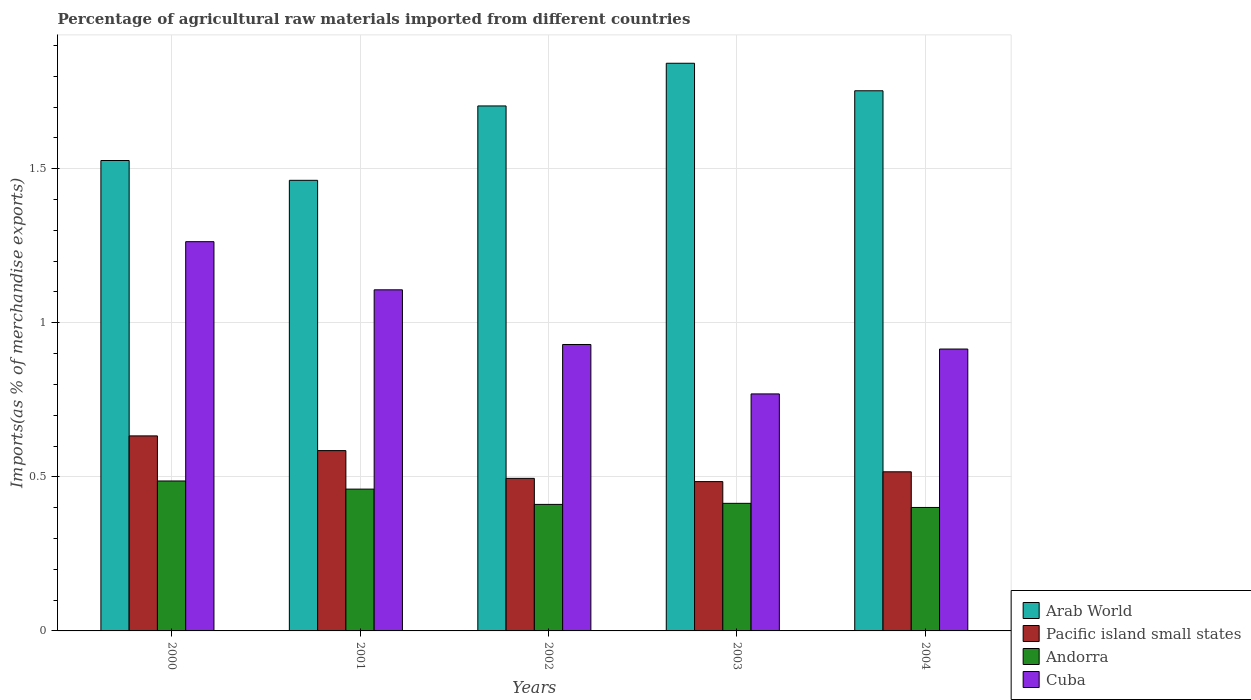How many groups of bars are there?
Offer a terse response. 5. Are the number of bars per tick equal to the number of legend labels?
Make the answer very short. Yes. How many bars are there on the 3rd tick from the left?
Provide a succinct answer. 4. What is the percentage of imports to different countries in Andorra in 2002?
Keep it short and to the point. 0.41. Across all years, what is the maximum percentage of imports to different countries in Cuba?
Ensure brevity in your answer.  1.26. Across all years, what is the minimum percentage of imports to different countries in Andorra?
Provide a succinct answer. 0.4. What is the total percentage of imports to different countries in Arab World in the graph?
Offer a terse response. 8.29. What is the difference between the percentage of imports to different countries in Arab World in 2002 and that in 2004?
Make the answer very short. -0.05. What is the difference between the percentage of imports to different countries in Cuba in 2000 and the percentage of imports to different countries in Arab World in 2001?
Your answer should be very brief. -0.2. What is the average percentage of imports to different countries in Andorra per year?
Your response must be concise. 0.43. In the year 2000, what is the difference between the percentage of imports to different countries in Arab World and percentage of imports to different countries in Cuba?
Your answer should be compact. 0.26. In how many years, is the percentage of imports to different countries in Pacific island small states greater than 0.6 %?
Your answer should be very brief. 1. What is the ratio of the percentage of imports to different countries in Cuba in 2001 to that in 2003?
Provide a short and direct response. 1.44. Is the difference between the percentage of imports to different countries in Arab World in 2000 and 2001 greater than the difference between the percentage of imports to different countries in Cuba in 2000 and 2001?
Your answer should be very brief. No. What is the difference between the highest and the second highest percentage of imports to different countries in Cuba?
Keep it short and to the point. 0.16. What is the difference between the highest and the lowest percentage of imports to different countries in Cuba?
Provide a succinct answer. 0.49. In how many years, is the percentage of imports to different countries in Arab World greater than the average percentage of imports to different countries in Arab World taken over all years?
Your response must be concise. 3. Is the sum of the percentage of imports to different countries in Arab World in 2002 and 2003 greater than the maximum percentage of imports to different countries in Cuba across all years?
Your answer should be compact. Yes. What does the 1st bar from the left in 2001 represents?
Your response must be concise. Arab World. What does the 4th bar from the right in 2003 represents?
Your response must be concise. Arab World. Are all the bars in the graph horizontal?
Offer a terse response. No. What is the difference between two consecutive major ticks on the Y-axis?
Keep it short and to the point. 0.5. Does the graph contain any zero values?
Your response must be concise. No. Where does the legend appear in the graph?
Your response must be concise. Bottom right. How are the legend labels stacked?
Your answer should be compact. Vertical. What is the title of the graph?
Your response must be concise. Percentage of agricultural raw materials imported from different countries. Does "Macao" appear as one of the legend labels in the graph?
Your response must be concise. No. What is the label or title of the Y-axis?
Ensure brevity in your answer.  Imports(as % of merchandise exports). What is the Imports(as % of merchandise exports) in Arab World in 2000?
Provide a short and direct response. 1.53. What is the Imports(as % of merchandise exports) of Pacific island small states in 2000?
Your answer should be compact. 0.63. What is the Imports(as % of merchandise exports) in Andorra in 2000?
Provide a succinct answer. 0.49. What is the Imports(as % of merchandise exports) of Cuba in 2000?
Your answer should be very brief. 1.26. What is the Imports(as % of merchandise exports) in Arab World in 2001?
Your response must be concise. 1.46. What is the Imports(as % of merchandise exports) of Pacific island small states in 2001?
Keep it short and to the point. 0.59. What is the Imports(as % of merchandise exports) in Andorra in 2001?
Provide a succinct answer. 0.46. What is the Imports(as % of merchandise exports) of Cuba in 2001?
Ensure brevity in your answer.  1.11. What is the Imports(as % of merchandise exports) of Arab World in 2002?
Keep it short and to the point. 1.7. What is the Imports(as % of merchandise exports) of Pacific island small states in 2002?
Your response must be concise. 0.5. What is the Imports(as % of merchandise exports) in Andorra in 2002?
Your response must be concise. 0.41. What is the Imports(as % of merchandise exports) of Cuba in 2002?
Your answer should be very brief. 0.93. What is the Imports(as % of merchandise exports) of Arab World in 2003?
Provide a short and direct response. 1.84. What is the Imports(as % of merchandise exports) in Pacific island small states in 2003?
Your answer should be very brief. 0.48. What is the Imports(as % of merchandise exports) of Andorra in 2003?
Give a very brief answer. 0.41. What is the Imports(as % of merchandise exports) in Cuba in 2003?
Keep it short and to the point. 0.77. What is the Imports(as % of merchandise exports) in Arab World in 2004?
Your answer should be very brief. 1.75. What is the Imports(as % of merchandise exports) in Pacific island small states in 2004?
Make the answer very short. 0.52. What is the Imports(as % of merchandise exports) of Andorra in 2004?
Provide a succinct answer. 0.4. What is the Imports(as % of merchandise exports) in Cuba in 2004?
Provide a short and direct response. 0.91. Across all years, what is the maximum Imports(as % of merchandise exports) of Arab World?
Your answer should be compact. 1.84. Across all years, what is the maximum Imports(as % of merchandise exports) in Pacific island small states?
Offer a terse response. 0.63. Across all years, what is the maximum Imports(as % of merchandise exports) in Andorra?
Offer a terse response. 0.49. Across all years, what is the maximum Imports(as % of merchandise exports) of Cuba?
Ensure brevity in your answer.  1.26. Across all years, what is the minimum Imports(as % of merchandise exports) in Arab World?
Provide a short and direct response. 1.46. Across all years, what is the minimum Imports(as % of merchandise exports) in Pacific island small states?
Your response must be concise. 0.48. Across all years, what is the minimum Imports(as % of merchandise exports) of Andorra?
Provide a succinct answer. 0.4. Across all years, what is the minimum Imports(as % of merchandise exports) in Cuba?
Offer a terse response. 0.77. What is the total Imports(as % of merchandise exports) of Arab World in the graph?
Ensure brevity in your answer.  8.29. What is the total Imports(as % of merchandise exports) of Pacific island small states in the graph?
Your answer should be compact. 2.71. What is the total Imports(as % of merchandise exports) in Andorra in the graph?
Ensure brevity in your answer.  2.17. What is the total Imports(as % of merchandise exports) in Cuba in the graph?
Your response must be concise. 4.98. What is the difference between the Imports(as % of merchandise exports) in Arab World in 2000 and that in 2001?
Ensure brevity in your answer.  0.06. What is the difference between the Imports(as % of merchandise exports) in Pacific island small states in 2000 and that in 2001?
Provide a succinct answer. 0.05. What is the difference between the Imports(as % of merchandise exports) of Andorra in 2000 and that in 2001?
Give a very brief answer. 0.03. What is the difference between the Imports(as % of merchandise exports) of Cuba in 2000 and that in 2001?
Ensure brevity in your answer.  0.16. What is the difference between the Imports(as % of merchandise exports) in Arab World in 2000 and that in 2002?
Ensure brevity in your answer.  -0.18. What is the difference between the Imports(as % of merchandise exports) in Pacific island small states in 2000 and that in 2002?
Offer a terse response. 0.14. What is the difference between the Imports(as % of merchandise exports) in Andorra in 2000 and that in 2002?
Ensure brevity in your answer.  0.08. What is the difference between the Imports(as % of merchandise exports) in Cuba in 2000 and that in 2002?
Keep it short and to the point. 0.33. What is the difference between the Imports(as % of merchandise exports) in Arab World in 2000 and that in 2003?
Give a very brief answer. -0.32. What is the difference between the Imports(as % of merchandise exports) of Pacific island small states in 2000 and that in 2003?
Provide a short and direct response. 0.15. What is the difference between the Imports(as % of merchandise exports) of Andorra in 2000 and that in 2003?
Keep it short and to the point. 0.07. What is the difference between the Imports(as % of merchandise exports) of Cuba in 2000 and that in 2003?
Give a very brief answer. 0.49. What is the difference between the Imports(as % of merchandise exports) of Arab World in 2000 and that in 2004?
Ensure brevity in your answer.  -0.23. What is the difference between the Imports(as % of merchandise exports) of Pacific island small states in 2000 and that in 2004?
Make the answer very short. 0.12. What is the difference between the Imports(as % of merchandise exports) in Andorra in 2000 and that in 2004?
Your answer should be very brief. 0.09. What is the difference between the Imports(as % of merchandise exports) in Cuba in 2000 and that in 2004?
Offer a very short reply. 0.35. What is the difference between the Imports(as % of merchandise exports) of Arab World in 2001 and that in 2002?
Give a very brief answer. -0.24. What is the difference between the Imports(as % of merchandise exports) of Pacific island small states in 2001 and that in 2002?
Your answer should be very brief. 0.09. What is the difference between the Imports(as % of merchandise exports) in Andorra in 2001 and that in 2002?
Your response must be concise. 0.05. What is the difference between the Imports(as % of merchandise exports) of Cuba in 2001 and that in 2002?
Your answer should be compact. 0.18. What is the difference between the Imports(as % of merchandise exports) of Arab World in 2001 and that in 2003?
Ensure brevity in your answer.  -0.38. What is the difference between the Imports(as % of merchandise exports) of Pacific island small states in 2001 and that in 2003?
Make the answer very short. 0.1. What is the difference between the Imports(as % of merchandise exports) in Andorra in 2001 and that in 2003?
Provide a short and direct response. 0.05. What is the difference between the Imports(as % of merchandise exports) of Cuba in 2001 and that in 2003?
Make the answer very short. 0.34. What is the difference between the Imports(as % of merchandise exports) in Arab World in 2001 and that in 2004?
Offer a terse response. -0.29. What is the difference between the Imports(as % of merchandise exports) of Pacific island small states in 2001 and that in 2004?
Provide a short and direct response. 0.07. What is the difference between the Imports(as % of merchandise exports) in Andorra in 2001 and that in 2004?
Your answer should be very brief. 0.06. What is the difference between the Imports(as % of merchandise exports) of Cuba in 2001 and that in 2004?
Your response must be concise. 0.19. What is the difference between the Imports(as % of merchandise exports) in Arab World in 2002 and that in 2003?
Offer a terse response. -0.14. What is the difference between the Imports(as % of merchandise exports) in Pacific island small states in 2002 and that in 2003?
Your response must be concise. 0.01. What is the difference between the Imports(as % of merchandise exports) in Andorra in 2002 and that in 2003?
Give a very brief answer. -0. What is the difference between the Imports(as % of merchandise exports) of Cuba in 2002 and that in 2003?
Your answer should be very brief. 0.16. What is the difference between the Imports(as % of merchandise exports) of Arab World in 2002 and that in 2004?
Give a very brief answer. -0.05. What is the difference between the Imports(as % of merchandise exports) of Pacific island small states in 2002 and that in 2004?
Offer a very short reply. -0.02. What is the difference between the Imports(as % of merchandise exports) of Andorra in 2002 and that in 2004?
Your answer should be very brief. 0.01. What is the difference between the Imports(as % of merchandise exports) of Cuba in 2002 and that in 2004?
Give a very brief answer. 0.01. What is the difference between the Imports(as % of merchandise exports) of Arab World in 2003 and that in 2004?
Your response must be concise. 0.09. What is the difference between the Imports(as % of merchandise exports) of Pacific island small states in 2003 and that in 2004?
Give a very brief answer. -0.03. What is the difference between the Imports(as % of merchandise exports) in Andorra in 2003 and that in 2004?
Provide a short and direct response. 0.01. What is the difference between the Imports(as % of merchandise exports) of Cuba in 2003 and that in 2004?
Provide a succinct answer. -0.15. What is the difference between the Imports(as % of merchandise exports) of Arab World in 2000 and the Imports(as % of merchandise exports) of Pacific island small states in 2001?
Your answer should be compact. 0.94. What is the difference between the Imports(as % of merchandise exports) in Arab World in 2000 and the Imports(as % of merchandise exports) in Andorra in 2001?
Your answer should be compact. 1.07. What is the difference between the Imports(as % of merchandise exports) of Arab World in 2000 and the Imports(as % of merchandise exports) of Cuba in 2001?
Your answer should be very brief. 0.42. What is the difference between the Imports(as % of merchandise exports) of Pacific island small states in 2000 and the Imports(as % of merchandise exports) of Andorra in 2001?
Your response must be concise. 0.17. What is the difference between the Imports(as % of merchandise exports) in Pacific island small states in 2000 and the Imports(as % of merchandise exports) in Cuba in 2001?
Offer a terse response. -0.47. What is the difference between the Imports(as % of merchandise exports) in Andorra in 2000 and the Imports(as % of merchandise exports) in Cuba in 2001?
Your answer should be very brief. -0.62. What is the difference between the Imports(as % of merchandise exports) in Arab World in 2000 and the Imports(as % of merchandise exports) in Pacific island small states in 2002?
Ensure brevity in your answer.  1.03. What is the difference between the Imports(as % of merchandise exports) in Arab World in 2000 and the Imports(as % of merchandise exports) in Andorra in 2002?
Give a very brief answer. 1.12. What is the difference between the Imports(as % of merchandise exports) in Arab World in 2000 and the Imports(as % of merchandise exports) in Cuba in 2002?
Your answer should be compact. 0.6. What is the difference between the Imports(as % of merchandise exports) of Pacific island small states in 2000 and the Imports(as % of merchandise exports) of Andorra in 2002?
Ensure brevity in your answer.  0.22. What is the difference between the Imports(as % of merchandise exports) of Pacific island small states in 2000 and the Imports(as % of merchandise exports) of Cuba in 2002?
Provide a succinct answer. -0.3. What is the difference between the Imports(as % of merchandise exports) of Andorra in 2000 and the Imports(as % of merchandise exports) of Cuba in 2002?
Provide a succinct answer. -0.44. What is the difference between the Imports(as % of merchandise exports) of Arab World in 2000 and the Imports(as % of merchandise exports) of Pacific island small states in 2003?
Give a very brief answer. 1.04. What is the difference between the Imports(as % of merchandise exports) in Arab World in 2000 and the Imports(as % of merchandise exports) in Andorra in 2003?
Ensure brevity in your answer.  1.11. What is the difference between the Imports(as % of merchandise exports) in Arab World in 2000 and the Imports(as % of merchandise exports) in Cuba in 2003?
Your response must be concise. 0.76. What is the difference between the Imports(as % of merchandise exports) of Pacific island small states in 2000 and the Imports(as % of merchandise exports) of Andorra in 2003?
Offer a very short reply. 0.22. What is the difference between the Imports(as % of merchandise exports) of Pacific island small states in 2000 and the Imports(as % of merchandise exports) of Cuba in 2003?
Offer a terse response. -0.14. What is the difference between the Imports(as % of merchandise exports) of Andorra in 2000 and the Imports(as % of merchandise exports) of Cuba in 2003?
Make the answer very short. -0.28. What is the difference between the Imports(as % of merchandise exports) in Arab World in 2000 and the Imports(as % of merchandise exports) in Pacific island small states in 2004?
Your answer should be compact. 1.01. What is the difference between the Imports(as % of merchandise exports) of Arab World in 2000 and the Imports(as % of merchandise exports) of Andorra in 2004?
Offer a terse response. 1.13. What is the difference between the Imports(as % of merchandise exports) of Arab World in 2000 and the Imports(as % of merchandise exports) of Cuba in 2004?
Offer a terse response. 0.61. What is the difference between the Imports(as % of merchandise exports) in Pacific island small states in 2000 and the Imports(as % of merchandise exports) in Andorra in 2004?
Your answer should be very brief. 0.23. What is the difference between the Imports(as % of merchandise exports) of Pacific island small states in 2000 and the Imports(as % of merchandise exports) of Cuba in 2004?
Your response must be concise. -0.28. What is the difference between the Imports(as % of merchandise exports) of Andorra in 2000 and the Imports(as % of merchandise exports) of Cuba in 2004?
Provide a succinct answer. -0.43. What is the difference between the Imports(as % of merchandise exports) of Arab World in 2001 and the Imports(as % of merchandise exports) of Pacific island small states in 2002?
Keep it short and to the point. 0.97. What is the difference between the Imports(as % of merchandise exports) of Arab World in 2001 and the Imports(as % of merchandise exports) of Andorra in 2002?
Your answer should be very brief. 1.05. What is the difference between the Imports(as % of merchandise exports) of Arab World in 2001 and the Imports(as % of merchandise exports) of Cuba in 2002?
Make the answer very short. 0.53. What is the difference between the Imports(as % of merchandise exports) of Pacific island small states in 2001 and the Imports(as % of merchandise exports) of Andorra in 2002?
Your response must be concise. 0.17. What is the difference between the Imports(as % of merchandise exports) in Pacific island small states in 2001 and the Imports(as % of merchandise exports) in Cuba in 2002?
Give a very brief answer. -0.34. What is the difference between the Imports(as % of merchandise exports) in Andorra in 2001 and the Imports(as % of merchandise exports) in Cuba in 2002?
Your answer should be compact. -0.47. What is the difference between the Imports(as % of merchandise exports) in Arab World in 2001 and the Imports(as % of merchandise exports) in Pacific island small states in 2003?
Offer a terse response. 0.98. What is the difference between the Imports(as % of merchandise exports) in Arab World in 2001 and the Imports(as % of merchandise exports) in Andorra in 2003?
Keep it short and to the point. 1.05. What is the difference between the Imports(as % of merchandise exports) of Arab World in 2001 and the Imports(as % of merchandise exports) of Cuba in 2003?
Offer a very short reply. 0.69. What is the difference between the Imports(as % of merchandise exports) in Pacific island small states in 2001 and the Imports(as % of merchandise exports) in Andorra in 2003?
Offer a terse response. 0.17. What is the difference between the Imports(as % of merchandise exports) of Pacific island small states in 2001 and the Imports(as % of merchandise exports) of Cuba in 2003?
Your answer should be very brief. -0.18. What is the difference between the Imports(as % of merchandise exports) of Andorra in 2001 and the Imports(as % of merchandise exports) of Cuba in 2003?
Give a very brief answer. -0.31. What is the difference between the Imports(as % of merchandise exports) of Arab World in 2001 and the Imports(as % of merchandise exports) of Pacific island small states in 2004?
Give a very brief answer. 0.95. What is the difference between the Imports(as % of merchandise exports) of Arab World in 2001 and the Imports(as % of merchandise exports) of Andorra in 2004?
Provide a short and direct response. 1.06. What is the difference between the Imports(as % of merchandise exports) in Arab World in 2001 and the Imports(as % of merchandise exports) in Cuba in 2004?
Keep it short and to the point. 0.55. What is the difference between the Imports(as % of merchandise exports) in Pacific island small states in 2001 and the Imports(as % of merchandise exports) in Andorra in 2004?
Offer a terse response. 0.18. What is the difference between the Imports(as % of merchandise exports) of Pacific island small states in 2001 and the Imports(as % of merchandise exports) of Cuba in 2004?
Make the answer very short. -0.33. What is the difference between the Imports(as % of merchandise exports) of Andorra in 2001 and the Imports(as % of merchandise exports) of Cuba in 2004?
Provide a succinct answer. -0.45. What is the difference between the Imports(as % of merchandise exports) of Arab World in 2002 and the Imports(as % of merchandise exports) of Pacific island small states in 2003?
Provide a succinct answer. 1.22. What is the difference between the Imports(as % of merchandise exports) of Arab World in 2002 and the Imports(as % of merchandise exports) of Andorra in 2003?
Your response must be concise. 1.29. What is the difference between the Imports(as % of merchandise exports) of Arab World in 2002 and the Imports(as % of merchandise exports) of Cuba in 2003?
Keep it short and to the point. 0.93. What is the difference between the Imports(as % of merchandise exports) in Pacific island small states in 2002 and the Imports(as % of merchandise exports) in Andorra in 2003?
Ensure brevity in your answer.  0.08. What is the difference between the Imports(as % of merchandise exports) in Pacific island small states in 2002 and the Imports(as % of merchandise exports) in Cuba in 2003?
Make the answer very short. -0.27. What is the difference between the Imports(as % of merchandise exports) in Andorra in 2002 and the Imports(as % of merchandise exports) in Cuba in 2003?
Keep it short and to the point. -0.36. What is the difference between the Imports(as % of merchandise exports) of Arab World in 2002 and the Imports(as % of merchandise exports) of Pacific island small states in 2004?
Give a very brief answer. 1.19. What is the difference between the Imports(as % of merchandise exports) in Arab World in 2002 and the Imports(as % of merchandise exports) in Andorra in 2004?
Your answer should be compact. 1.3. What is the difference between the Imports(as % of merchandise exports) in Arab World in 2002 and the Imports(as % of merchandise exports) in Cuba in 2004?
Make the answer very short. 0.79. What is the difference between the Imports(as % of merchandise exports) in Pacific island small states in 2002 and the Imports(as % of merchandise exports) in Andorra in 2004?
Keep it short and to the point. 0.09. What is the difference between the Imports(as % of merchandise exports) in Pacific island small states in 2002 and the Imports(as % of merchandise exports) in Cuba in 2004?
Your response must be concise. -0.42. What is the difference between the Imports(as % of merchandise exports) in Andorra in 2002 and the Imports(as % of merchandise exports) in Cuba in 2004?
Make the answer very short. -0.5. What is the difference between the Imports(as % of merchandise exports) in Arab World in 2003 and the Imports(as % of merchandise exports) in Pacific island small states in 2004?
Make the answer very short. 1.33. What is the difference between the Imports(as % of merchandise exports) of Arab World in 2003 and the Imports(as % of merchandise exports) of Andorra in 2004?
Provide a short and direct response. 1.44. What is the difference between the Imports(as % of merchandise exports) of Arab World in 2003 and the Imports(as % of merchandise exports) of Cuba in 2004?
Ensure brevity in your answer.  0.93. What is the difference between the Imports(as % of merchandise exports) in Pacific island small states in 2003 and the Imports(as % of merchandise exports) in Andorra in 2004?
Your answer should be very brief. 0.08. What is the difference between the Imports(as % of merchandise exports) of Pacific island small states in 2003 and the Imports(as % of merchandise exports) of Cuba in 2004?
Make the answer very short. -0.43. What is the difference between the Imports(as % of merchandise exports) of Andorra in 2003 and the Imports(as % of merchandise exports) of Cuba in 2004?
Offer a very short reply. -0.5. What is the average Imports(as % of merchandise exports) in Arab World per year?
Offer a very short reply. 1.66. What is the average Imports(as % of merchandise exports) of Pacific island small states per year?
Keep it short and to the point. 0.54. What is the average Imports(as % of merchandise exports) in Andorra per year?
Your response must be concise. 0.43. What is the average Imports(as % of merchandise exports) in Cuba per year?
Offer a terse response. 1. In the year 2000, what is the difference between the Imports(as % of merchandise exports) of Arab World and Imports(as % of merchandise exports) of Pacific island small states?
Your answer should be compact. 0.89. In the year 2000, what is the difference between the Imports(as % of merchandise exports) of Arab World and Imports(as % of merchandise exports) of Cuba?
Offer a terse response. 0.26. In the year 2000, what is the difference between the Imports(as % of merchandise exports) of Pacific island small states and Imports(as % of merchandise exports) of Andorra?
Provide a short and direct response. 0.15. In the year 2000, what is the difference between the Imports(as % of merchandise exports) of Pacific island small states and Imports(as % of merchandise exports) of Cuba?
Your response must be concise. -0.63. In the year 2000, what is the difference between the Imports(as % of merchandise exports) in Andorra and Imports(as % of merchandise exports) in Cuba?
Keep it short and to the point. -0.78. In the year 2001, what is the difference between the Imports(as % of merchandise exports) in Arab World and Imports(as % of merchandise exports) in Pacific island small states?
Your answer should be compact. 0.88. In the year 2001, what is the difference between the Imports(as % of merchandise exports) of Arab World and Imports(as % of merchandise exports) of Cuba?
Offer a very short reply. 0.36. In the year 2001, what is the difference between the Imports(as % of merchandise exports) of Pacific island small states and Imports(as % of merchandise exports) of Andorra?
Keep it short and to the point. 0.12. In the year 2001, what is the difference between the Imports(as % of merchandise exports) in Pacific island small states and Imports(as % of merchandise exports) in Cuba?
Your answer should be very brief. -0.52. In the year 2001, what is the difference between the Imports(as % of merchandise exports) of Andorra and Imports(as % of merchandise exports) of Cuba?
Provide a succinct answer. -0.65. In the year 2002, what is the difference between the Imports(as % of merchandise exports) of Arab World and Imports(as % of merchandise exports) of Pacific island small states?
Offer a very short reply. 1.21. In the year 2002, what is the difference between the Imports(as % of merchandise exports) in Arab World and Imports(as % of merchandise exports) in Andorra?
Provide a succinct answer. 1.29. In the year 2002, what is the difference between the Imports(as % of merchandise exports) in Arab World and Imports(as % of merchandise exports) in Cuba?
Your answer should be compact. 0.77. In the year 2002, what is the difference between the Imports(as % of merchandise exports) in Pacific island small states and Imports(as % of merchandise exports) in Andorra?
Provide a succinct answer. 0.08. In the year 2002, what is the difference between the Imports(as % of merchandise exports) of Pacific island small states and Imports(as % of merchandise exports) of Cuba?
Your answer should be compact. -0.43. In the year 2002, what is the difference between the Imports(as % of merchandise exports) in Andorra and Imports(as % of merchandise exports) in Cuba?
Your response must be concise. -0.52. In the year 2003, what is the difference between the Imports(as % of merchandise exports) in Arab World and Imports(as % of merchandise exports) in Pacific island small states?
Make the answer very short. 1.36. In the year 2003, what is the difference between the Imports(as % of merchandise exports) of Arab World and Imports(as % of merchandise exports) of Andorra?
Offer a terse response. 1.43. In the year 2003, what is the difference between the Imports(as % of merchandise exports) in Arab World and Imports(as % of merchandise exports) in Cuba?
Give a very brief answer. 1.07. In the year 2003, what is the difference between the Imports(as % of merchandise exports) of Pacific island small states and Imports(as % of merchandise exports) of Andorra?
Offer a terse response. 0.07. In the year 2003, what is the difference between the Imports(as % of merchandise exports) of Pacific island small states and Imports(as % of merchandise exports) of Cuba?
Provide a succinct answer. -0.28. In the year 2003, what is the difference between the Imports(as % of merchandise exports) in Andorra and Imports(as % of merchandise exports) in Cuba?
Provide a short and direct response. -0.36. In the year 2004, what is the difference between the Imports(as % of merchandise exports) in Arab World and Imports(as % of merchandise exports) in Pacific island small states?
Keep it short and to the point. 1.24. In the year 2004, what is the difference between the Imports(as % of merchandise exports) in Arab World and Imports(as % of merchandise exports) in Andorra?
Your response must be concise. 1.35. In the year 2004, what is the difference between the Imports(as % of merchandise exports) of Arab World and Imports(as % of merchandise exports) of Cuba?
Make the answer very short. 0.84. In the year 2004, what is the difference between the Imports(as % of merchandise exports) in Pacific island small states and Imports(as % of merchandise exports) in Andorra?
Your answer should be very brief. 0.12. In the year 2004, what is the difference between the Imports(as % of merchandise exports) in Pacific island small states and Imports(as % of merchandise exports) in Cuba?
Your response must be concise. -0.4. In the year 2004, what is the difference between the Imports(as % of merchandise exports) of Andorra and Imports(as % of merchandise exports) of Cuba?
Your answer should be compact. -0.51. What is the ratio of the Imports(as % of merchandise exports) of Arab World in 2000 to that in 2001?
Your answer should be very brief. 1.04. What is the ratio of the Imports(as % of merchandise exports) of Pacific island small states in 2000 to that in 2001?
Your answer should be compact. 1.08. What is the ratio of the Imports(as % of merchandise exports) in Andorra in 2000 to that in 2001?
Your answer should be very brief. 1.06. What is the ratio of the Imports(as % of merchandise exports) in Cuba in 2000 to that in 2001?
Provide a succinct answer. 1.14. What is the ratio of the Imports(as % of merchandise exports) in Arab World in 2000 to that in 2002?
Your answer should be compact. 0.9. What is the ratio of the Imports(as % of merchandise exports) in Pacific island small states in 2000 to that in 2002?
Keep it short and to the point. 1.28. What is the ratio of the Imports(as % of merchandise exports) of Andorra in 2000 to that in 2002?
Your response must be concise. 1.19. What is the ratio of the Imports(as % of merchandise exports) of Cuba in 2000 to that in 2002?
Give a very brief answer. 1.36. What is the ratio of the Imports(as % of merchandise exports) in Arab World in 2000 to that in 2003?
Offer a terse response. 0.83. What is the ratio of the Imports(as % of merchandise exports) in Pacific island small states in 2000 to that in 2003?
Offer a very short reply. 1.31. What is the ratio of the Imports(as % of merchandise exports) of Andorra in 2000 to that in 2003?
Ensure brevity in your answer.  1.18. What is the ratio of the Imports(as % of merchandise exports) in Cuba in 2000 to that in 2003?
Offer a terse response. 1.64. What is the ratio of the Imports(as % of merchandise exports) in Arab World in 2000 to that in 2004?
Give a very brief answer. 0.87. What is the ratio of the Imports(as % of merchandise exports) of Pacific island small states in 2000 to that in 2004?
Your response must be concise. 1.23. What is the ratio of the Imports(as % of merchandise exports) of Andorra in 2000 to that in 2004?
Provide a short and direct response. 1.21. What is the ratio of the Imports(as % of merchandise exports) of Cuba in 2000 to that in 2004?
Your answer should be very brief. 1.38. What is the ratio of the Imports(as % of merchandise exports) of Arab World in 2001 to that in 2002?
Offer a terse response. 0.86. What is the ratio of the Imports(as % of merchandise exports) of Pacific island small states in 2001 to that in 2002?
Give a very brief answer. 1.18. What is the ratio of the Imports(as % of merchandise exports) in Andorra in 2001 to that in 2002?
Your answer should be compact. 1.12. What is the ratio of the Imports(as % of merchandise exports) in Cuba in 2001 to that in 2002?
Your answer should be very brief. 1.19. What is the ratio of the Imports(as % of merchandise exports) in Arab World in 2001 to that in 2003?
Make the answer very short. 0.79. What is the ratio of the Imports(as % of merchandise exports) in Pacific island small states in 2001 to that in 2003?
Offer a very short reply. 1.21. What is the ratio of the Imports(as % of merchandise exports) of Andorra in 2001 to that in 2003?
Offer a very short reply. 1.11. What is the ratio of the Imports(as % of merchandise exports) in Cuba in 2001 to that in 2003?
Your response must be concise. 1.44. What is the ratio of the Imports(as % of merchandise exports) of Arab World in 2001 to that in 2004?
Provide a succinct answer. 0.83. What is the ratio of the Imports(as % of merchandise exports) of Pacific island small states in 2001 to that in 2004?
Your answer should be compact. 1.13. What is the ratio of the Imports(as % of merchandise exports) in Andorra in 2001 to that in 2004?
Keep it short and to the point. 1.15. What is the ratio of the Imports(as % of merchandise exports) of Cuba in 2001 to that in 2004?
Provide a succinct answer. 1.21. What is the ratio of the Imports(as % of merchandise exports) in Arab World in 2002 to that in 2003?
Offer a terse response. 0.92. What is the ratio of the Imports(as % of merchandise exports) in Pacific island small states in 2002 to that in 2003?
Make the answer very short. 1.02. What is the ratio of the Imports(as % of merchandise exports) in Andorra in 2002 to that in 2003?
Make the answer very short. 0.99. What is the ratio of the Imports(as % of merchandise exports) of Cuba in 2002 to that in 2003?
Make the answer very short. 1.21. What is the ratio of the Imports(as % of merchandise exports) of Arab World in 2002 to that in 2004?
Ensure brevity in your answer.  0.97. What is the ratio of the Imports(as % of merchandise exports) in Pacific island small states in 2002 to that in 2004?
Your answer should be compact. 0.96. What is the ratio of the Imports(as % of merchandise exports) of Andorra in 2002 to that in 2004?
Give a very brief answer. 1.02. What is the ratio of the Imports(as % of merchandise exports) of Cuba in 2002 to that in 2004?
Your response must be concise. 1.02. What is the ratio of the Imports(as % of merchandise exports) of Arab World in 2003 to that in 2004?
Your response must be concise. 1.05. What is the ratio of the Imports(as % of merchandise exports) in Pacific island small states in 2003 to that in 2004?
Make the answer very short. 0.94. What is the ratio of the Imports(as % of merchandise exports) in Andorra in 2003 to that in 2004?
Make the answer very short. 1.03. What is the ratio of the Imports(as % of merchandise exports) in Cuba in 2003 to that in 2004?
Your answer should be compact. 0.84. What is the difference between the highest and the second highest Imports(as % of merchandise exports) of Arab World?
Provide a short and direct response. 0.09. What is the difference between the highest and the second highest Imports(as % of merchandise exports) of Pacific island small states?
Offer a terse response. 0.05. What is the difference between the highest and the second highest Imports(as % of merchandise exports) in Andorra?
Your response must be concise. 0.03. What is the difference between the highest and the second highest Imports(as % of merchandise exports) of Cuba?
Keep it short and to the point. 0.16. What is the difference between the highest and the lowest Imports(as % of merchandise exports) in Arab World?
Ensure brevity in your answer.  0.38. What is the difference between the highest and the lowest Imports(as % of merchandise exports) of Pacific island small states?
Offer a terse response. 0.15. What is the difference between the highest and the lowest Imports(as % of merchandise exports) in Andorra?
Your answer should be very brief. 0.09. What is the difference between the highest and the lowest Imports(as % of merchandise exports) in Cuba?
Provide a short and direct response. 0.49. 